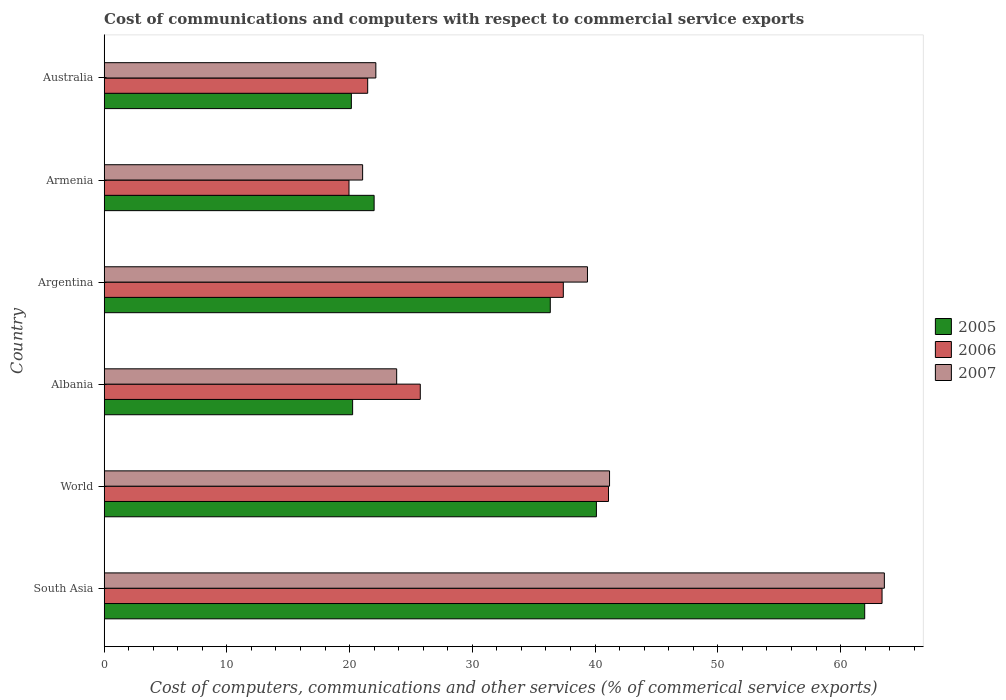How many groups of bars are there?
Give a very brief answer. 6. Are the number of bars on each tick of the Y-axis equal?
Your response must be concise. Yes. How many bars are there on the 1st tick from the top?
Offer a very short reply. 3. How many bars are there on the 3rd tick from the bottom?
Make the answer very short. 3. In how many cases, is the number of bars for a given country not equal to the number of legend labels?
Provide a short and direct response. 0. What is the cost of communications and computers in 2006 in Albania?
Your answer should be very brief. 25.76. Across all countries, what is the maximum cost of communications and computers in 2006?
Keep it short and to the point. 63.38. Across all countries, what is the minimum cost of communications and computers in 2005?
Your answer should be very brief. 20.14. In which country was the cost of communications and computers in 2005 maximum?
Provide a short and direct response. South Asia. In which country was the cost of communications and computers in 2006 minimum?
Give a very brief answer. Armenia. What is the total cost of communications and computers in 2005 in the graph?
Offer a terse response. 200.81. What is the difference between the cost of communications and computers in 2007 in Albania and that in Australia?
Offer a very short reply. 1.7. What is the difference between the cost of communications and computers in 2005 in Armenia and the cost of communications and computers in 2007 in Australia?
Provide a succinct answer. -0.14. What is the average cost of communications and computers in 2007 per country?
Make the answer very short. 35.19. What is the difference between the cost of communications and computers in 2006 and cost of communications and computers in 2005 in World?
Offer a very short reply. 0.98. What is the ratio of the cost of communications and computers in 2006 in Albania to that in Argentina?
Provide a succinct answer. 0.69. What is the difference between the highest and the second highest cost of communications and computers in 2006?
Provide a short and direct response. 22.29. What is the difference between the highest and the lowest cost of communications and computers in 2007?
Your answer should be very brief. 42.51. In how many countries, is the cost of communications and computers in 2006 greater than the average cost of communications and computers in 2006 taken over all countries?
Ensure brevity in your answer.  3. Is the sum of the cost of communications and computers in 2007 in Argentina and Australia greater than the maximum cost of communications and computers in 2005 across all countries?
Make the answer very short. No. What does the 3rd bar from the bottom in Albania represents?
Your answer should be compact. 2007. Is it the case that in every country, the sum of the cost of communications and computers in 2005 and cost of communications and computers in 2007 is greater than the cost of communications and computers in 2006?
Your response must be concise. Yes. How many bars are there?
Provide a succinct answer. 18. Are all the bars in the graph horizontal?
Your answer should be very brief. Yes. What is the difference between two consecutive major ticks on the X-axis?
Your response must be concise. 10. Are the values on the major ticks of X-axis written in scientific E-notation?
Your answer should be compact. No. Does the graph contain grids?
Ensure brevity in your answer.  No. How many legend labels are there?
Keep it short and to the point. 3. What is the title of the graph?
Provide a short and direct response. Cost of communications and computers with respect to commercial service exports. Does "2010" appear as one of the legend labels in the graph?
Offer a very short reply. No. What is the label or title of the X-axis?
Your response must be concise. Cost of computers, communications and other services (% of commerical service exports). What is the Cost of computers, communications and other services (% of commerical service exports) of 2005 in South Asia?
Make the answer very short. 61.97. What is the Cost of computers, communications and other services (% of commerical service exports) of 2006 in South Asia?
Keep it short and to the point. 63.38. What is the Cost of computers, communications and other services (% of commerical service exports) of 2007 in South Asia?
Offer a terse response. 63.57. What is the Cost of computers, communications and other services (% of commerical service exports) in 2005 in World?
Provide a succinct answer. 40.11. What is the Cost of computers, communications and other services (% of commerical service exports) in 2006 in World?
Offer a very short reply. 41.09. What is the Cost of computers, communications and other services (% of commerical service exports) in 2007 in World?
Ensure brevity in your answer.  41.18. What is the Cost of computers, communications and other services (% of commerical service exports) of 2005 in Albania?
Provide a succinct answer. 20.24. What is the Cost of computers, communications and other services (% of commerical service exports) in 2006 in Albania?
Your response must be concise. 25.76. What is the Cost of computers, communications and other services (% of commerical service exports) in 2007 in Albania?
Provide a short and direct response. 23.83. What is the Cost of computers, communications and other services (% of commerical service exports) of 2005 in Argentina?
Give a very brief answer. 36.35. What is the Cost of computers, communications and other services (% of commerical service exports) in 2006 in Argentina?
Make the answer very short. 37.41. What is the Cost of computers, communications and other services (% of commerical service exports) in 2007 in Argentina?
Your response must be concise. 39.38. What is the Cost of computers, communications and other services (% of commerical service exports) of 2005 in Armenia?
Offer a very short reply. 22. What is the Cost of computers, communications and other services (% of commerical service exports) of 2006 in Armenia?
Your answer should be very brief. 19.95. What is the Cost of computers, communications and other services (% of commerical service exports) of 2007 in Armenia?
Your answer should be very brief. 21.06. What is the Cost of computers, communications and other services (% of commerical service exports) of 2005 in Australia?
Make the answer very short. 20.14. What is the Cost of computers, communications and other services (% of commerical service exports) in 2006 in Australia?
Ensure brevity in your answer.  21.47. What is the Cost of computers, communications and other services (% of commerical service exports) in 2007 in Australia?
Make the answer very short. 22.14. Across all countries, what is the maximum Cost of computers, communications and other services (% of commerical service exports) of 2005?
Offer a very short reply. 61.97. Across all countries, what is the maximum Cost of computers, communications and other services (% of commerical service exports) in 2006?
Keep it short and to the point. 63.38. Across all countries, what is the maximum Cost of computers, communications and other services (% of commerical service exports) in 2007?
Your answer should be compact. 63.57. Across all countries, what is the minimum Cost of computers, communications and other services (% of commerical service exports) in 2005?
Your answer should be very brief. 20.14. Across all countries, what is the minimum Cost of computers, communications and other services (% of commerical service exports) of 2006?
Your answer should be very brief. 19.95. Across all countries, what is the minimum Cost of computers, communications and other services (% of commerical service exports) in 2007?
Offer a very short reply. 21.06. What is the total Cost of computers, communications and other services (% of commerical service exports) of 2005 in the graph?
Offer a terse response. 200.81. What is the total Cost of computers, communications and other services (% of commerical service exports) in 2006 in the graph?
Provide a succinct answer. 209.07. What is the total Cost of computers, communications and other services (% of commerical service exports) in 2007 in the graph?
Your answer should be very brief. 211.16. What is the difference between the Cost of computers, communications and other services (% of commerical service exports) of 2005 in South Asia and that in World?
Offer a terse response. 21.86. What is the difference between the Cost of computers, communications and other services (% of commerical service exports) of 2006 in South Asia and that in World?
Ensure brevity in your answer.  22.29. What is the difference between the Cost of computers, communications and other services (% of commerical service exports) in 2007 in South Asia and that in World?
Your response must be concise. 22.39. What is the difference between the Cost of computers, communications and other services (% of commerical service exports) of 2005 in South Asia and that in Albania?
Offer a very short reply. 41.72. What is the difference between the Cost of computers, communications and other services (% of commerical service exports) in 2006 in South Asia and that in Albania?
Your answer should be compact. 37.62. What is the difference between the Cost of computers, communications and other services (% of commerical service exports) in 2007 in South Asia and that in Albania?
Your response must be concise. 39.74. What is the difference between the Cost of computers, communications and other services (% of commerical service exports) in 2005 in South Asia and that in Argentina?
Provide a succinct answer. 25.62. What is the difference between the Cost of computers, communications and other services (% of commerical service exports) of 2006 in South Asia and that in Argentina?
Ensure brevity in your answer.  25.97. What is the difference between the Cost of computers, communications and other services (% of commerical service exports) in 2007 in South Asia and that in Argentina?
Ensure brevity in your answer.  24.19. What is the difference between the Cost of computers, communications and other services (% of commerical service exports) in 2005 in South Asia and that in Armenia?
Make the answer very short. 39.97. What is the difference between the Cost of computers, communications and other services (% of commerical service exports) in 2006 in South Asia and that in Armenia?
Provide a short and direct response. 43.43. What is the difference between the Cost of computers, communications and other services (% of commerical service exports) of 2007 in South Asia and that in Armenia?
Offer a very short reply. 42.51. What is the difference between the Cost of computers, communications and other services (% of commerical service exports) in 2005 in South Asia and that in Australia?
Keep it short and to the point. 41.83. What is the difference between the Cost of computers, communications and other services (% of commerical service exports) of 2006 in South Asia and that in Australia?
Your answer should be compact. 41.91. What is the difference between the Cost of computers, communications and other services (% of commerical service exports) of 2007 in South Asia and that in Australia?
Your response must be concise. 41.43. What is the difference between the Cost of computers, communications and other services (% of commerical service exports) in 2005 in World and that in Albania?
Make the answer very short. 19.86. What is the difference between the Cost of computers, communications and other services (% of commerical service exports) in 2006 in World and that in Albania?
Offer a very short reply. 15.33. What is the difference between the Cost of computers, communications and other services (% of commerical service exports) of 2007 in World and that in Albania?
Offer a terse response. 17.34. What is the difference between the Cost of computers, communications and other services (% of commerical service exports) in 2005 in World and that in Argentina?
Give a very brief answer. 3.76. What is the difference between the Cost of computers, communications and other services (% of commerical service exports) of 2006 in World and that in Argentina?
Offer a terse response. 3.68. What is the difference between the Cost of computers, communications and other services (% of commerical service exports) of 2007 in World and that in Argentina?
Offer a very short reply. 1.8. What is the difference between the Cost of computers, communications and other services (% of commerical service exports) in 2005 in World and that in Armenia?
Keep it short and to the point. 18.11. What is the difference between the Cost of computers, communications and other services (% of commerical service exports) of 2006 in World and that in Armenia?
Offer a very short reply. 21.14. What is the difference between the Cost of computers, communications and other services (% of commerical service exports) of 2007 in World and that in Armenia?
Keep it short and to the point. 20.12. What is the difference between the Cost of computers, communications and other services (% of commerical service exports) in 2005 in World and that in Australia?
Make the answer very short. 19.97. What is the difference between the Cost of computers, communications and other services (% of commerical service exports) in 2006 in World and that in Australia?
Keep it short and to the point. 19.62. What is the difference between the Cost of computers, communications and other services (% of commerical service exports) in 2007 in World and that in Australia?
Provide a short and direct response. 19.04. What is the difference between the Cost of computers, communications and other services (% of commerical service exports) in 2005 in Albania and that in Argentina?
Keep it short and to the point. -16.1. What is the difference between the Cost of computers, communications and other services (% of commerical service exports) of 2006 in Albania and that in Argentina?
Your answer should be compact. -11.65. What is the difference between the Cost of computers, communications and other services (% of commerical service exports) of 2007 in Albania and that in Argentina?
Provide a short and direct response. -15.54. What is the difference between the Cost of computers, communications and other services (% of commerical service exports) in 2005 in Albania and that in Armenia?
Provide a succinct answer. -1.75. What is the difference between the Cost of computers, communications and other services (% of commerical service exports) in 2006 in Albania and that in Armenia?
Ensure brevity in your answer.  5.81. What is the difference between the Cost of computers, communications and other services (% of commerical service exports) in 2007 in Albania and that in Armenia?
Provide a succinct answer. 2.77. What is the difference between the Cost of computers, communications and other services (% of commerical service exports) of 2005 in Albania and that in Australia?
Offer a terse response. 0.1. What is the difference between the Cost of computers, communications and other services (% of commerical service exports) of 2006 in Albania and that in Australia?
Provide a short and direct response. 4.29. What is the difference between the Cost of computers, communications and other services (% of commerical service exports) of 2007 in Albania and that in Australia?
Provide a succinct answer. 1.7. What is the difference between the Cost of computers, communications and other services (% of commerical service exports) in 2005 in Argentina and that in Armenia?
Offer a very short reply. 14.35. What is the difference between the Cost of computers, communications and other services (% of commerical service exports) in 2006 in Argentina and that in Armenia?
Your response must be concise. 17.46. What is the difference between the Cost of computers, communications and other services (% of commerical service exports) of 2007 in Argentina and that in Armenia?
Your response must be concise. 18.32. What is the difference between the Cost of computers, communications and other services (% of commerical service exports) in 2005 in Argentina and that in Australia?
Give a very brief answer. 16.21. What is the difference between the Cost of computers, communications and other services (% of commerical service exports) in 2006 in Argentina and that in Australia?
Keep it short and to the point. 15.94. What is the difference between the Cost of computers, communications and other services (% of commerical service exports) of 2007 in Argentina and that in Australia?
Provide a succinct answer. 17.24. What is the difference between the Cost of computers, communications and other services (% of commerical service exports) in 2005 in Armenia and that in Australia?
Provide a short and direct response. 1.85. What is the difference between the Cost of computers, communications and other services (% of commerical service exports) in 2006 in Armenia and that in Australia?
Make the answer very short. -1.52. What is the difference between the Cost of computers, communications and other services (% of commerical service exports) of 2007 in Armenia and that in Australia?
Offer a terse response. -1.08. What is the difference between the Cost of computers, communications and other services (% of commerical service exports) in 2005 in South Asia and the Cost of computers, communications and other services (% of commerical service exports) in 2006 in World?
Your answer should be very brief. 20.88. What is the difference between the Cost of computers, communications and other services (% of commerical service exports) in 2005 in South Asia and the Cost of computers, communications and other services (% of commerical service exports) in 2007 in World?
Provide a succinct answer. 20.79. What is the difference between the Cost of computers, communications and other services (% of commerical service exports) of 2006 in South Asia and the Cost of computers, communications and other services (% of commerical service exports) of 2007 in World?
Provide a short and direct response. 22.2. What is the difference between the Cost of computers, communications and other services (% of commerical service exports) in 2005 in South Asia and the Cost of computers, communications and other services (% of commerical service exports) in 2006 in Albania?
Your answer should be very brief. 36.21. What is the difference between the Cost of computers, communications and other services (% of commerical service exports) in 2005 in South Asia and the Cost of computers, communications and other services (% of commerical service exports) in 2007 in Albania?
Ensure brevity in your answer.  38.13. What is the difference between the Cost of computers, communications and other services (% of commerical service exports) in 2006 in South Asia and the Cost of computers, communications and other services (% of commerical service exports) in 2007 in Albania?
Offer a very short reply. 39.55. What is the difference between the Cost of computers, communications and other services (% of commerical service exports) of 2005 in South Asia and the Cost of computers, communications and other services (% of commerical service exports) of 2006 in Argentina?
Offer a terse response. 24.56. What is the difference between the Cost of computers, communications and other services (% of commerical service exports) in 2005 in South Asia and the Cost of computers, communications and other services (% of commerical service exports) in 2007 in Argentina?
Your response must be concise. 22.59. What is the difference between the Cost of computers, communications and other services (% of commerical service exports) in 2006 in South Asia and the Cost of computers, communications and other services (% of commerical service exports) in 2007 in Argentina?
Offer a terse response. 24. What is the difference between the Cost of computers, communications and other services (% of commerical service exports) of 2005 in South Asia and the Cost of computers, communications and other services (% of commerical service exports) of 2006 in Armenia?
Provide a short and direct response. 42.02. What is the difference between the Cost of computers, communications and other services (% of commerical service exports) in 2005 in South Asia and the Cost of computers, communications and other services (% of commerical service exports) in 2007 in Armenia?
Keep it short and to the point. 40.91. What is the difference between the Cost of computers, communications and other services (% of commerical service exports) in 2006 in South Asia and the Cost of computers, communications and other services (% of commerical service exports) in 2007 in Armenia?
Offer a terse response. 42.32. What is the difference between the Cost of computers, communications and other services (% of commerical service exports) in 2005 in South Asia and the Cost of computers, communications and other services (% of commerical service exports) in 2006 in Australia?
Offer a terse response. 40.5. What is the difference between the Cost of computers, communications and other services (% of commerical service exports) in 2005 in South Asia and the Cost of computers, communications and other services (% of commerical service exports) in 2007 in Australia?
Ensure brevity in your answer.  39.83. What is the difference between the Cost of computers, communications and other services (% of commerical service exports) of 2006 in South Asia and the Cost of computers, communications and other services (% of commerical service exports) of 2007 in Australia?
Make the answer very short. 41.24. What is the difference between the Cost of computers, communications and other services (% of commerical service exports) in 2005 in World and the Cost of computers, communications and other services (% of commerical service exports) in 2006 in Albania?
Your response must be concise. 14.35. What is the difference between the Cost of computers, communications and other services (% of commerical service exports) in 2005 in World and the Cost of computers, communications and other services (% of commerical service exports) in 2007 in Albania?
Make the answer very short. 16.27. What is the difference between the Cost of computers, communications and other services (% of commerical service exports) of 2006 in World and the Cost of computers, communications and other services (% of commerical service exports) of 2007 in Albania?
Keep it short and to the point. 17.26. What is the difference between the Cost of computers, communications and other services (% of commerical service exports) in 2005 in World and the Cost of computers, communications and other services (% of commerical service exports) in 2006 in Argentina?
Ensure brevity in your answer.  2.7. What is the difference between the Cost of computers, communications and other services (% of commerical service exports) in 2005 in World and the Cost of computers, communications and other services (% of commerical service exports) in 2007 in Argentina?
Provide a succinct answer. 0.73. What is the difference between the Cost of computers, communications and other services (% of commerical service exports) in 2006 in World and the Cost of computers, communications and other services (% of commerical service exports) in 2007 in Argentina?
Your answer should be very brief. 1.71. What is the difference between the Cost of computers, communications and other services (% of commerical service exports) in 2005 in World and the Cost of computers, communications and other services (% of commerical service exports) in 2006 in Armenia?
Your answer should be very brief. 20.16. What is the difference between the Cost of computers, communications and other services (% of commerical service exports) of 2005 in World and the Cost of computers, communications and other services (% of commerical service exports) of 2007 in Armenia?
Ensure brevity in your answer.  19.05. What is the difference between the Cost of computers, communications and other services (% of commerical service exports) of 2006 in World and the Cost of computers, communications and other services (% of commerical service exports) of 2007 in Armenia?
Your response must be concise. 20.03. What is the difference between the Cost of computers, communications and other services (% of commerical service exports) in 2005 in World and the Cost of computers, communications and other services (% of commerical service exports) in 2006 in Australia?
Offer a terse response. 18.64. What is the difference between the Cost of computers, communications and other services (% of commerical service exports) in 2005 in World and the Cost of computers, communications and other services (% of commerical service exports) in 2007 in Australia?
Offer a terse response. 17.97. What is the difference between the Cost of computers, communications and other services (% of commerical service exports) of 2006 in World and the Cost of computers, communications and other services (% of commerical service exports) of 2007 in Australia?
Ensure brevity in your answer.  18.96. What is the difference between the Cost of computers, communications and other services (% of commerical service exports) in 2005 in Albania and the Cost of computers, communications and other services (% of commerical service exports) in 2006 in Argentina?
Offer a very short reply. -17.17. What is the difference between the Cost of computers, communications and other services (% of commerical service exports) of 2005 in Albania and the Cost of computers, communications and other services (% of commerical service exports) of 2007 in Argentina?
Your response must be concise. -19.13. What is the difference between the Cost of computers, communications and other services (% of commerical service exports) of 2006 in Albania and the Cost of computers, communications and other services (% of commerical service exports) of 2007 in Argentina?
Make the answer very short. -13.62. What is the difference between the Cost of computers, communications and other services (% of commerical service exports) of 2005 in Albania and the Cost of computers, communications and other services (% of commerical service exports) of 2006 in Armenia?
Your answer should be very brief. 0.29. What is the difference between the Cost of computers, communications and other services (% of commerical service exports) in 2005 in Albania and the Cost of computers, communications and other services (% of commerical service exports) in 2007 in Armenia?
Provide a succinct answer. -0.82. What is the difference between the Cost of computers, communications and other services (% of commerical service exports) of 2006 in Albania and the Cost of computers, communications and other services (% of commerical service exports) of 2007 in Armenia?
Provide a short and direct response. 4.7. What is the difference between the Cost of computers, communications and other services (% of commerical service exports) of 2005 in Albania and the Cost of computers, communications and other services (% of commerical service exports) of 2006 in Australia?
Provide a short and direct response. -1.23. What is the difference between the Cost of computers, communications and other services (% of commerical service exports) in 2005 in Albania and the Cost of computers, communications and other services (% of commerical service exports) in 2007 in Australia?
Your answer should be compact. -1.89. What is the difference between the Cost of computers, communications and other services (% of commerical service exports) in 2006 in Albania and the Cost of computers, communications and other services (% of commerical service exports) in 2007 in Australia?
Your answer should be compact. 3.62. What is the difference between the Cost of computers, communications and other services (% of commerical service exports) of 2005 in Argentina and the Cost of computers, communications and other services (% of commerical service exports) of 2006 in Armenia?
Provide a short and direct response. 16.4. What is the difference between the Cost of computers, communications and other services (% of commerical service exports) in 2005 in Argentina and the Cost of computers, communications and other services (% of commerical service exports) in 2007 in Armenia?
Offer a very short reply. 15.29. What is the difference between the Cost of computers, communications and other services (% of commerical service exports) in 2006 in Argentina and the Cost of computers, communications and other services (% of commerical service exports) in 2007 in Armenia?
Offer a very short reply. 16.35. What is the difference between the Cost of computers, communications and other services (% of commerical service exports) in 2005 in Argentina and the Cost of computers, communications and other services (% of commerical service exports) in 2006 in Australia?
Provide a short and direct response. 14.88. What is the difference between the Cost of computers, communications and other services (% of commerical service exports) of 2005 in Argentina and the Cost of computers, communications and other services (% of commerical service exports) of 2007 in Australia?
Make the answer very short. 14.21. What is the difference between the Cost of computers, communications and other services (% of commerical service exports) of 2006 in Argentina and the Cost of computers, communications and other services (% of commerical service exports) of 2007 in Australia?
Provide a short and direct response. 15.27. What is the difference between the Cost of computers, communications and other services (% of commerical service exports) of 2005 in Armenia and the Cost of computers, communications and other services (% of commerical service exports) of 2006 in Australia?
Provide a short and direct response. 0.52. What is the difference between the Cost of computers, communications and other services (% of commerical service exports) of 2005 in Armenia and the Cost of computers, communications and other services (% of commerical service exports) of 2007 in Australia?
Your answer should be very brief. -0.14. What is the difference between the Cost of computers, communications and other services (% of commerical service exports) of 2006 in Armenia and the Cost of computers, communications and other services (% of commerical service exports) of 2007 in Australia?
Your response must be concise. -2.19. What is the average Cost of computers, communications and other services (% of commerical service exports) in 2005 per country?
Make the answer very short. 33.47. What is the average Cost of computers, communications and other services (% of commerical service exports) of 2006 per country?
Give a very brief answer. 34.84. What is the average Cost of computers, communications and other services (% of commerical service exports) of 2007 per country?
Make the answer very short. 35.19. What is the difference between the Cost of computers, communications and other services (% of commerical service exports) of 2005 and Cost of computers, communications and other services (% of commerical service exports) of 2006 in South Asia?
Ensure brevity in your answer.  -1.41. What is the difference between the Cost of computers, communications and other services (% of commerical service exports) in 2005 and Cost of computers, communications and other services (% of commerical service exports) in 2007 in South Asia?
Your response must be concise. -1.6. What is the difference between the Cost of computers, communications and other services (% of commerical service exports) of 2006 and Cost of computers, communications and other services (% of commerical service exports) of 2007 in South Asia?
Make the answer very short. -0.19. What is the difference between the Cost of computers, communications and other services (% of commerical service exports) of 2005 and Cost of computers, communications and other services (% of commerical service exports) of 2006 in World?
Provide a short and direct response. -0.98. What is the difference between the Cost of computers, communications and other services (% of commerical service exports) of 2005 and Cost of computers, communications and other services (% of commerical service exports) of 2007 in World?
Keep it short and to the point. -1.07. What is the difference between the Cost of computers, communications and other services (% of commerical service exports) in 2006 and Cost of computers, communications and other services (% of commerical service exports) in 2007 in World?
Offer a very short reply. -0.09. What is the difference between the Cost of computers, communications and other services (% of commerical service exports) in 2005 and Cost of computers, communications and other services (% of commerical service exports) in 2006 in Albania?
Provide a short and direct response. -5.51. What is the difference between the Cost of computers, communications and other services (% of commerical service exports) in 2005 and Cost of computers, communications and other services (% of commerical service exports) in 2007 in Albania?
Provide a succinct answer. -3.59. What is the difference between the Cost of computers, communications and other services (% of commerical service exports) in 2006 and Cost of computers, communications and other services (% of commerical service exports) in 2007 in Albania?
Make the answer very short. 1.92. What is the difference between the Cost of computers, communications and other services (% of commerical service exports) of 2005 and Cost of computers, communications and other services (% of commerical service exports) of 2006 in Argentina?
Make the answer very short. -1.06. What is the difference between the Cost of computers, communications and other services (% of commerical service exports) of 2005 and Cost of computers, communications and other services (% of commerical service exports) of 2007 in Argentina?
Ensure brevity in your answer.  -3.03. What is the difference between the Cost of computers, communications and other services (% of commerical service exports) in 2006 and Cost of computers, communications and other services (% of commerical service exports) in 2007 in Argentina?
Your response must be concise. -1.97. What is the difference between the Cost of computers, communications and other services (% of commerical service exports) in 2005 and Cost of computers, communications and other services (% of commerical service exports) in 2006 in Armenia?
Give a very brief answer. 2.05. What is the difference between the Cost of computers, communications and other services (% of commerical service exports) of 2005 and Cost of computers, communications and other services (% of commerical service exports) of 2007 in Armenia?
Your answer should be compact. 0.94. What is the difference between the Cost of computers, communications and other services (% of commerical service exports) in 2006 and Cost of computers, communications and other services (% of commerical service exports) in 2007 in Armenia?
Provide a succinct answer. -1.11. What is the difference between the Cost of computers, communications and other services (% of commerical service exports) of 2005 and Cost of computers, communications and other services (% of commerical service exports) of 2006 in Australia?
Your response must be concise. -1.33. What is the difference between the Cost of computers, communications and other services (% of commerical service exports) in 2005 and Cost of computers, communications and other services (% of commerical service exports) in 2007 in Australia?
Offer a terse response. -1.99. What is the difference between the Cost of computers, communications and other services (% of commerical service exports) of 2006 and Cost of computers, communications and other services (% of commerical service exports) of 2007 in Australia?
Make the answer very short. -0.66. What is the ratio of the Cost of computers, communications and other services (% of commerical service exports) of 2005 in South Asia to that in World?
Provide a short and direct response. 1.54. What is the ratio of the Cost of computers, communications and other services (% of commerical service exports) in 2006 in South Asia to that in World?
Your answer should be very brief. 1.54. What is the ratio of the Cost of computers, communications and other services (% of commerical service exports) of 2007 in South Asia to that in World?
Keep it short and to the point. 1.54. What is the ratio of the Cost of computers, communications and other services (% of commerical service exports) of 2005 in South Asia to that in Albania?
Keep it short and to the point. 3.06. What is the ratio of the Cost of computers, communications and other services (% of commerical service exports) in 2006 in South Asia to that in Albania?
Your answer should be very brief. 2.46. What is the ratio of the Cost of computers, communications and other services (% of commerical service exports) in 2007 in South Asia to that in Albania?
Your answer should be compact. 2.67. What is the ratio of the Cost of computers, communications and other services (% of commerical service exports) in 2005 in South Asia to that in Argentina?
Offer a terse response. 1.7. What is the ratio of the Cost of computers, communications and other services (% of commerical service exports) of 2006 in South Asia to that in Argentina?
Your answer should be compact. 1.69. What is the ratio of the Cost of computers, communications and other services (% of commerical service exports) in 2007 in South Asia to that in Argentina?
Give a very brief answer. 1.61. What is the ratio of the Cost of computers, communications and other services (% of commerical service exports) of 2005 in South Asia to that in Armenia?
Your answer should be compact. 2.82. What is the ratio of the Cost of computers, communications and other services (% of commerical service exports) of 2006 in South Asia to that in Armenia?
Make the answer very short. 3.18. What is the ratio of the Cost of computers, communications and other services (% of commerical service exports) of 2007 in South Asia to that in Armenia?
Provide a short and direct response. 3.02. What is the ratio of the Cost of computers, communications and other services (% of commerical service exports) of 2005 in South Asia to that in Australia?
Make the answer very short. 3.08. What is the ratio of the Cost of computers, communications and other services (% of commerical service exports) of 2006 in South Asia to that in Australia?
Give a very brief answer. 2.95. What is the ratio of the Cost of computers, communications and other services (% of commerical service exports) in 2007 in South Asia to that in Australia?
Offer a terse response. 2.87. What is the ratio of the Cost of computers, communications and other services (% of commerical service exports) of 2005 in World to that in Albania?
Ensure brevity in your answer.  1.98. What is the ratio of the Cost of computers, communications and other services (% of commerical service exports) in 2006 in World to that in Albania?
Keep it short and to the point. 1.6. What is the ratio of the Cost of computers, communications and other services (% of commerical service exports) of 2007 in World to that in Albania?
Keep it short and to the point. 1.73. What is the ratio of the Cost of computers, communications and other services (% of commerical service exports) of 2005 in World to that in Argentina?
Ensure brevity in your answer.  1.1. What is the ratio of the Cost of computers, communications and other services (% of commerical service exports) of 2006 in World to that in Argentina?
Give a very brief answer. 1.1. What is the ratio of the Cost of computers, communications and other services (% of commerical service exports) of 2007 in World to that in Argentina?
Ensure brevity in your answer.  1.05. What is the ratio of the Cost of computers, communications and other services (% of commerical service exports) in 2005 in World to that in Armenia?
Your response must be concise. 1.82. What is the ratio of the Cost of computers, communications and other services (% of commerical service exports) in 2006 in World to that in Armenia?
Offer a very short reply. 2.06. What is the ratio of the Cost of computers, communications and other services (% of commerical service exports) in 2007 in World to that in Armenia?
Make the answer very short. 1.96. What is the ratio of the Cost of computers, communications and other services (% of commerical service exports) in 2005 in World to that in Australia?
Offer a very short reply. 1.99. What is the ratio of the Cost of computers, communications and other services (% of commerical service exports) in 2006 in World to that in Australia?
Your answer should be compact. 1.91. What is the ratio of the Cost of computers, communications and other services (% of commerical service exports) of 2007 in World to that in Australia?
Ensure brevity in your answer.  1.86. What is the ratio of the Cost of computers, communications and other services (% of commerical service exports) of 2005 in Albania to that in Argentina?
Offer a very short reply. 0.56. What is the ratio of the Cost of computers, communications and other services (% of commerical service exports) of 2006 in Albania to that in Argentina?
Your answer should be very brief. 0.69. What is the ratio of the Cost of computers, communications and other services (% of commerical service exports) of 2007 in Albania to that in Argentina?
Make the answer very short. 0.61. What is the ratio of the Cost of computers, communications and other services (% of commerical service exports) in 2005 in Albania to that in Armenia?
Offer a terse response. 0.92. What is the ratio of the Cost of computers, communications and other services (% of commerical service exports) of 2006 in Albania to that in Armenia?
Offer a terse response. 1.29. What is the ratio of the Cost of computers, communications and other services (% of commerical service exports) in 2007 in Albania to that in Armenia?
Keep it short and to the point. 1.13. What is the ratio of the Cost of computers, communications and other services (% of commerical service exports) of 2006 in Albania to that in Australia?
Your answer should be compact. 1.2. What is the ratio of the Cost of computers, communications and other services (% of commerical service exports) of 2007 in Albania to that in Australia?
Ensure brevity in your answer.  1.08. What is the ratio of the Cost of computers, communications and other services (% of commerical service exports) of 2005 in Argentina to that in Armenia?
Provide a succinct answer. 1.65. What is the ratio of the Cost of computers, communications and other services (% of commerical service exports) of 2006 in Argentina to that in Armenia?
Your answer should be compact. 1.88. What is the ratio of the Cost of computers, communications and other services (% of commerical service exports) of 2007 in Argentina to that in Armenia?
Keep it short and to the point. 1.87. What is the ratio of the Cost of computers, communications and other services (% of commerical service exports) of 2005 in Argentina to that in Australia?
Make the answer very short. 1.8. What is the ratio of the Cost of computers, communications and other services (% of commerical service exports) in 2006 in Argentina to that in Australia?
Provide a succinct answer. 1.74. What is the ratio of the Cost of computers, communications and other services (% of commerical service exports) of 2007 in Argentina to that in Australia?
Keep it short and to the point. 1.78. What is the ratio of the Cost of computers, communications and other services (% of commerical service exports) in 2005 in Armenia to that in Australia?
Provide a succinct answer. 1.09. What is the ratio of the Cost of computers, communications and other services (% of commerical service exports) of 2006 in Armenia to that in Australia?
Your answer should be compact. 0.93. What is the ratio of the Cost of computers, communications and other services (% of commerical service exports) in 2007 in Armenia to that in Australia?
Your answer should be very brief. 0.95. What is the difference between the highest and the second highest Cost of computers, communications and other services (% of commerical service exports) of 2005?
Offer a terse response. 21.86. What is the difference between the highest and the second highest Cost of computers, communications and other services (% of commerical service exports) of 2006?
Provide a succinct answer. 22.29. What is the difference between the highest and the second highest Cost of computers, communications and other services (% of commerical service exports) in 2007?
Ensure brevity in your answer.  22.39. What is the difference between the highest and the lowest Cost of computers, communications and other services (% of commerical service exports) of 2005?
Provide a succinct answer. 41.83. What is the difference between the highest and the lowest Cost of computers, communications and other services (% of commerical service exports) in 2006?
Provide a succinct answer. 43.43. What is the difference between the highest and the lowest Cost of computers, communications and other services (% of commerical service exports) of 2007?
Make the answer very short. 42.51. 